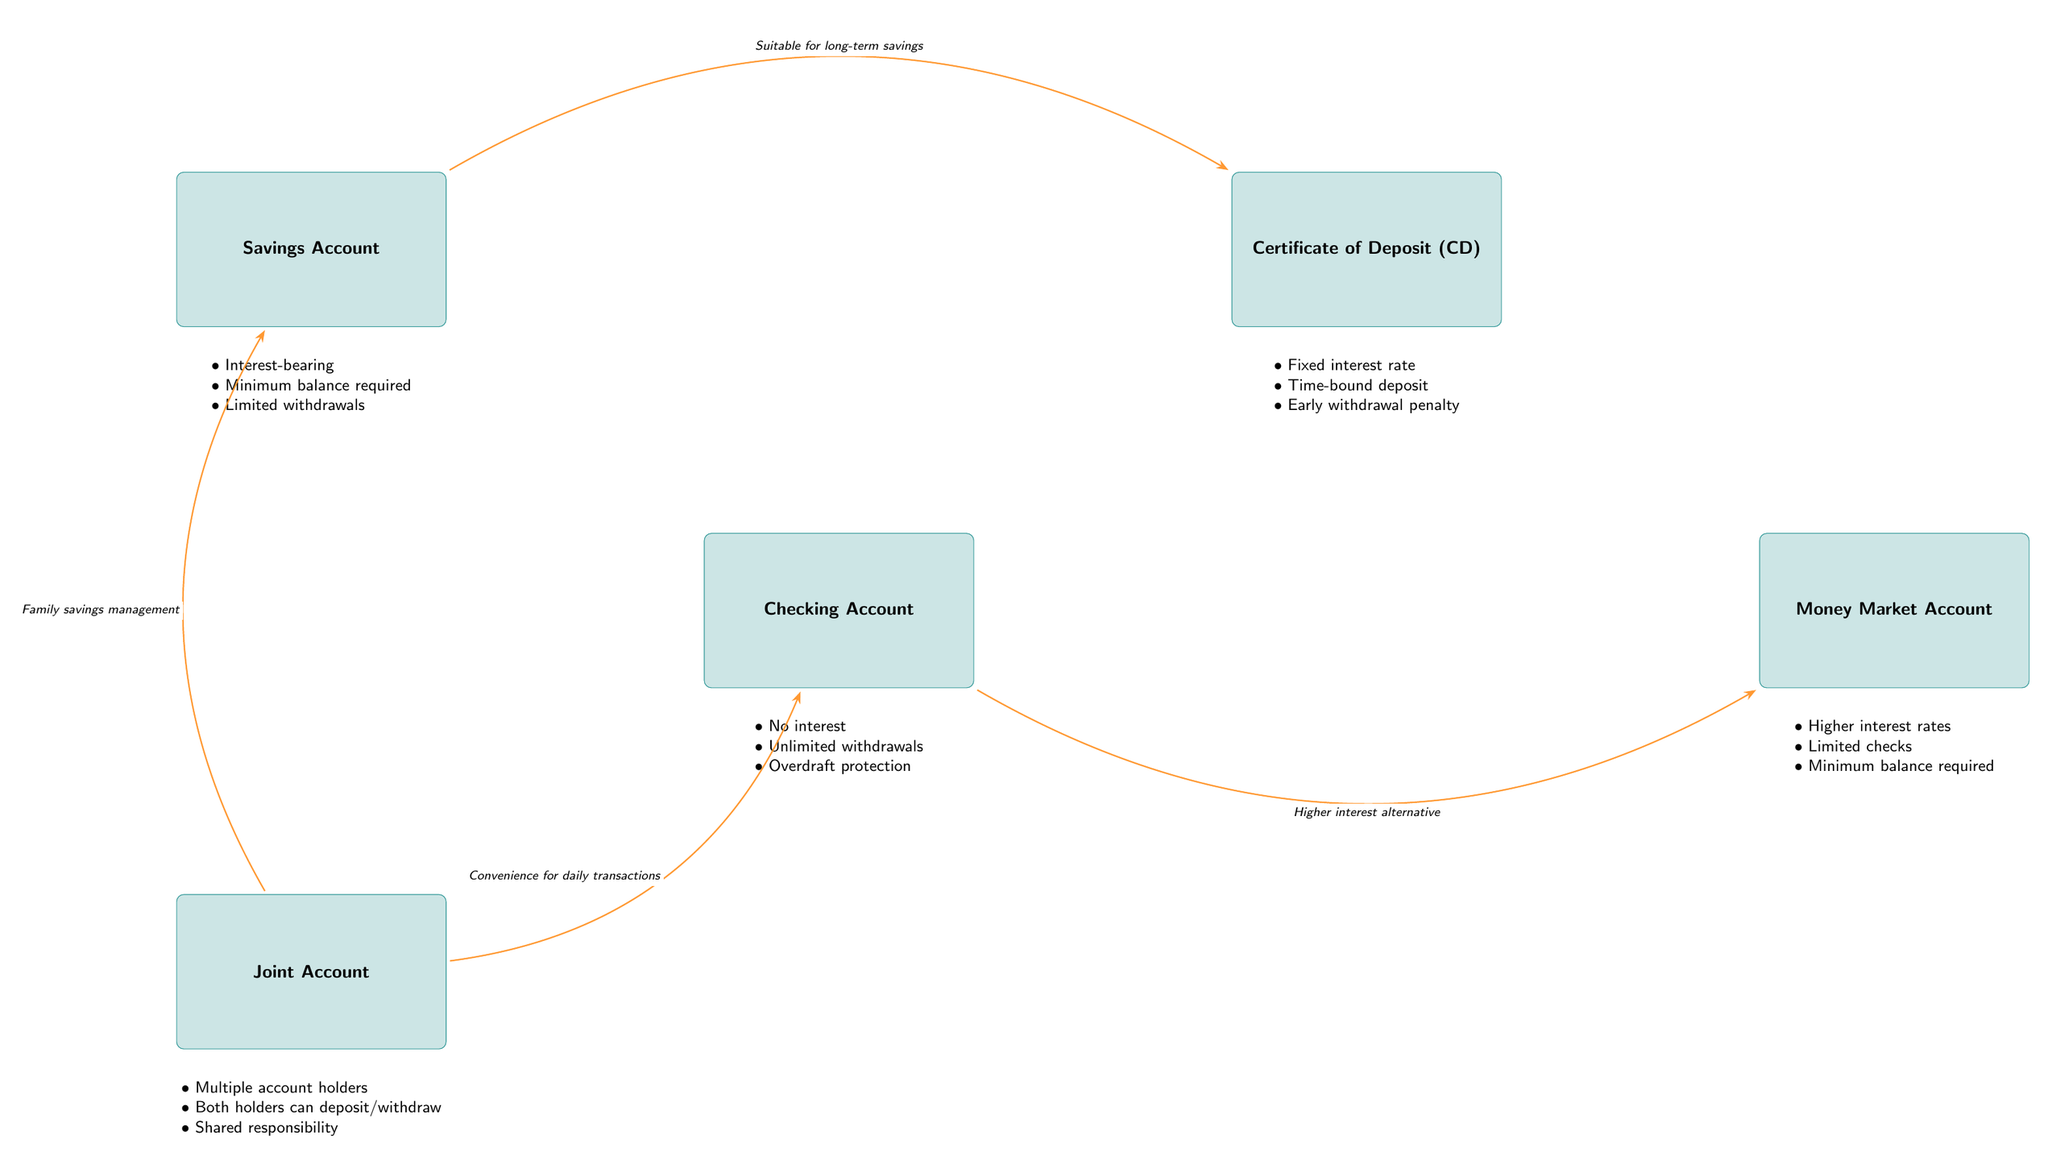What type of account is a Savings Account? The diagram indicates that a Savings Account is an account that is interest-bearing, requires a minimum balance, and has limited withdrawals.
Answer: Savings Account How many connections are there in the diagram? By counting the arrows (connections) between accounts, we find there are four connections: two between checking and other accounts, and one from savings to CD, and one from joint to checking.
Answer: 4 Which account has a fixed interest rate? The account labeled "Certificate of Deposit (CD)" is specifically noted to have a fixed interest rate, along with being time-bound and having an early withdrawal penalty.
Answer: Certificate of Deposit What do Checking and Money Market accounts have in common? Both accounts allow unlimited withdrawals, however, the Money Market Account also has higher interest rates and requires a minimum balance.
Answer: Unlimited withdrawals What is the relationship between Joint Account and Checking Account? The diagram shows a connection where the Joint Account is linked to the Checking Account, indicating convenience for daily transactions, meaning both account holders can perform transactions.
Answer: Convenience for daily transactions Which account is suitable for long-term savings? The Savings Account is described with the connection labeled "Suitable for long-term savings," indicating its primary purpose compared to others.
Answer: Savings Account What is a key feature of Money Market Accounts? Money Market accounts are described as having higher interest rates along with limited check-writing capabilities and minimum balance requirements.
Answer: Higher interest rates How many account holders can be on a Joint Account? The diagram indicates that a Joint Account can have multiple account holders, meaning more than one individual can share that account.
Answer: Multiple account holders What is the penalty associated with early withdrawal in a CD? The Certificate of Deposit (CD) clearly states it has an early withdrawal penalty, which is a consequence of taking funds out before the agreed term ends.
Answer: Early withdrawal penalty 